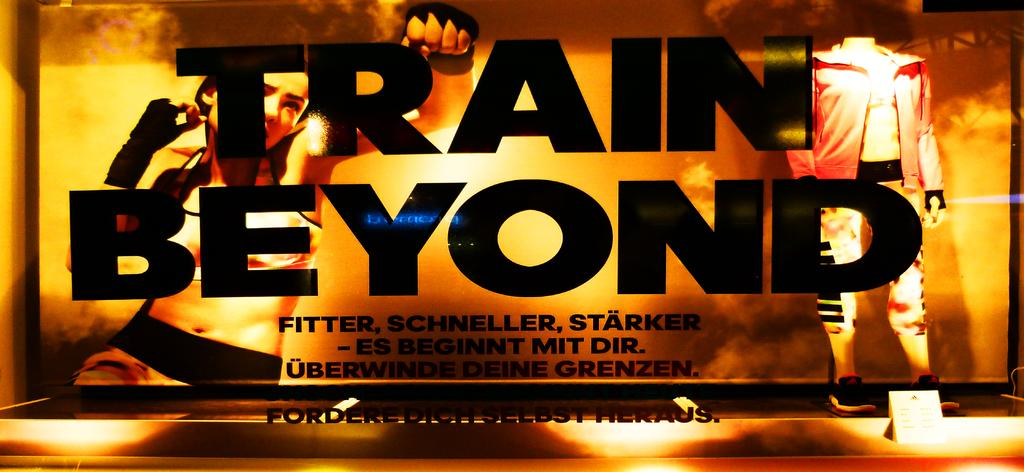<image>
Offer a succinct explanation of the picture presented. An ad is titled Train Beyond and shows people working out. 